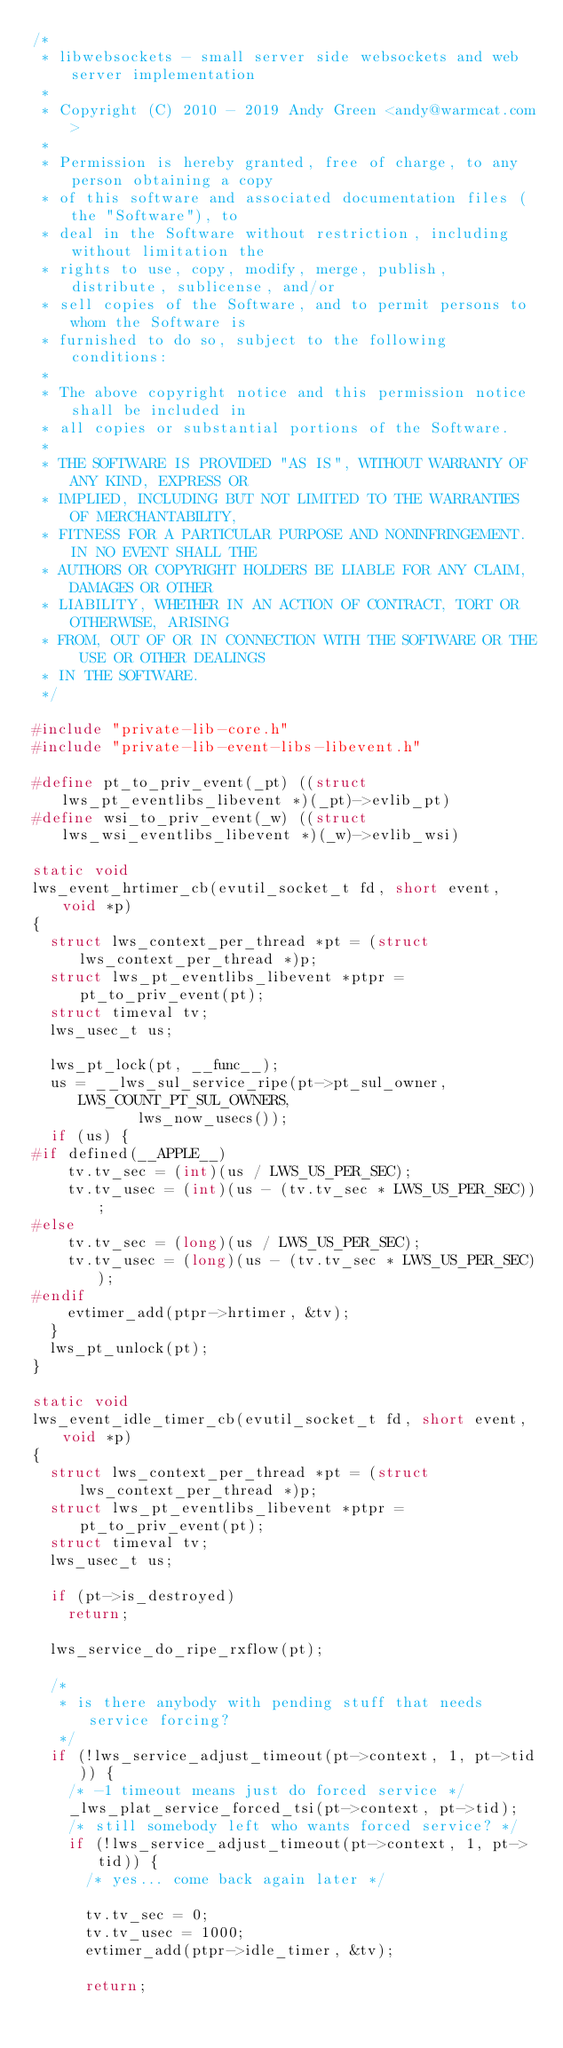<code> <loc_0><loc_0><loc_500><loc_500><_C_>/*
 * libwebsockets - small server side websockets and web server implementation
 *
 * Copyright (C) 2010 - 2019 Andy Green <andy@warmcat.com>
 *
 * Permission is hereby granted, free of charge, to any person obtaining a copy
 * of this software and associated documentation files (the "Software"), to
 * deal in the Software without restriction, including without limitation the
 * rights to use, copy, modify, merge, publish, distribute, sublicense, and/or
 * sell copies of the Software, and to permit persons to whom the Software is
 * furnished to do so, subject to the following conditions:
 *
 * The above copyright notice and this permission notice shall be included in
 * all copies or substantial portions of the Software.
 *
 * THE SOFTWARE IS PROVIDED "AS IS", WITHOUT WARRANTY OF ANY KIND, EXPRESS OR
 * IMPLIED, INCLUDING BUT NOT LIMITED TO THE WARRANTIES OF MERCHANTABILITY,
 * FITNESS FOR A PARTICULAR PURPOSE AND NONINFRINGEMENT. IN NO EVENT SHALL THE
 * AUTHORS OR COPYRIGHT HOLDERS BE LIABLE FOR ANY CLAIM, DAMAGES OR OTHER
 * LIABILITY, WHETHER IN AN ACTION OF CONTRACT, TORT OR OTHERWISE, ARISING
 * FROM, OUT OF OR IN CONNECTION WITH THE SOFTWARE OR THE USE OR OTHER DEALINGS
 * IN THE SOFTWARE.
 */

#include "private-lib-core.h"
#include "private-lib-event-libs-libevent.h"

#define pt_to_priv_event(_pt) ((struct lws_pt_eventlibs_libevent *)(_pt)->evlib_pt)
#define wsi_to_priv_event(_w) ((struct lws_wsi_eventlibs_libevent *)(_w)->evlib_wsi)

static void
lws_event_hrtimer_cb(evutil_socket_t fd, short event, void *p)
{
	struct lws_context_per_thread *pt = (struct lws_context_per_thread *)p;
	struct lws_pt_eventlibs_libevent *ptpr = pt_to_priv_event(pt);
	struct timeval tv;
	lws_usec_t us;

	lws_pt_lock(pt, __func__);
	us = __lws_sul_service_ripe(pt->pt_sul_owner, LWS_COUNT_PT_SUL_OWNERS,
				    lws_now_usecs());
	if (us) {
#if defined(__APPLE__)
		tv.tv_sec = (int)(us / LWS_US_PER_SEC);
		tv.tv_usec = (int)(us - (tv.tv_sec * LWS_US_PER_SEC));
#else
		tv.tv_sec = (long)(us / LWS_US_PER_SEC);
		tv.tv_usec = (long)(us - (tv.tv_sec * LWS_US_PER_SEC));
#endif
		evtimer_add(ptpr->hrtimer, &tv);
	}
	lws_pt_unlock(pt);
}

static void
lws_event_idle_timer_cb(evutil_socket_t fd, short event, void *p)
{
	struct lws_context_per_thread *pt = (struct lws_context_per_thread *)p;
	struct lws_pt_eventlibs_libevent *ptpr = pt_to_priv_event(pt);
	struct timeval tv;
	lws_usec_t us;

	if (pt->is_destroyed)
		return;

	lws_service_do_ripe_rxflow(pt);

	/*
	 * is there anybody with pending stuff that needs service forcing?
	 */
	if (!lws_service_adjust_timeout(pt->context, 1, pt->tid)) {
		/* -1 timeout means just do forced service */
		_lws_plat_service_forced_tsi(pt->context, pt->tid);
		/* still somebody left who wants forced service? */
		if (!lws_service_adjust_timeout(pt->context, 1, pt->tid)) {
			/* yes... come back again later */

			tv.tv_sec = 0;
			tv.tv_usec = 1000;
			evtimer_add(ptpr->idle_timer, &tv);

			return;</code> 